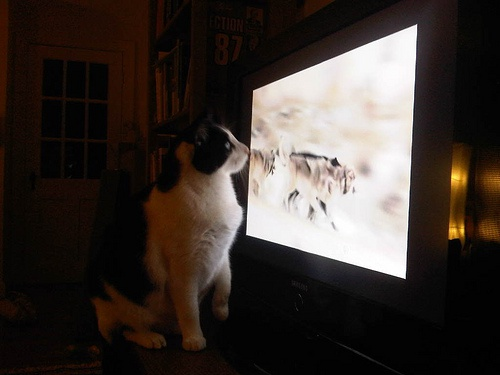Describe the objects in this image and their specific colors. I can see tv in black, white, darkgray, and lightgray tones, cat in black, maroon, gray, and darkgray tones, book in black tones, book in black and maroon tones, and book in black and maroon tones in this image. 